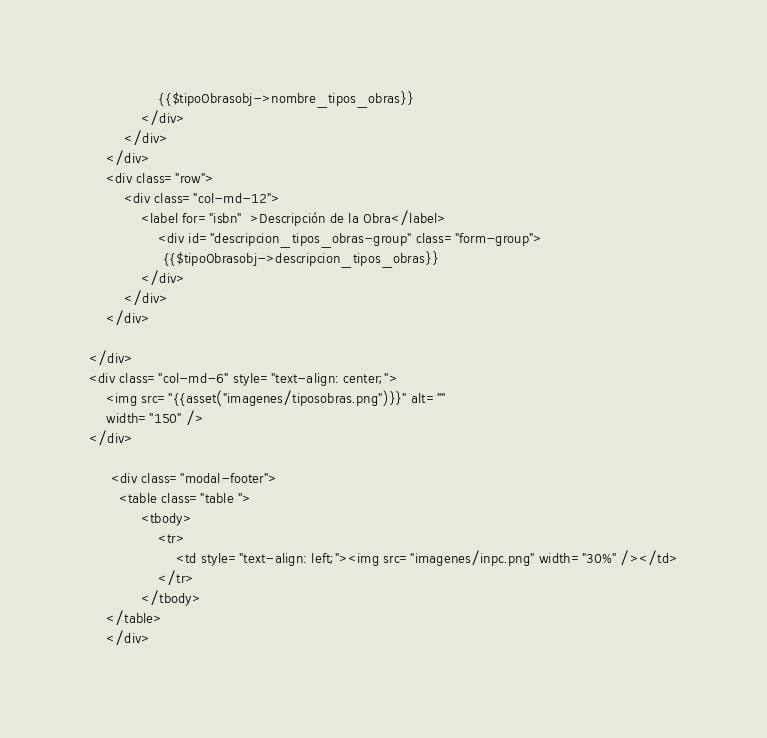<code> <loc_0><loc_0><loc_500><loc_500><_PHP_>                {{$tipoObrasobj->nombre_tipos_obras}}
            </div>
		</div>
	</div>
	<div class="row">
	    <div class="col-md-12">
	    	<label for="isbn"  >Descripción de la Obra</label>    
                <div id="descripcion_tipos_obras-group" class="form-group">
                 {{$tipoObrasobj->descripcion_tipos_obras}}
            </div>
	    </div>
	</div>
	
</div>
<div class="col-md-6" style="text-align: center;">
	<img src="{{asset("imagenes/tiposobras.png")}}" alt=""
	width="150" />
</div>

     <div class="modal-footer">
       <table class="table ">    
            <tbody>
                <tr>
                    <td style="text-align: left;"><img src="imagenes/inpc.png" width="30%" /></td>
                </tr>
            </tbody>
    </table>
    </div>  
</code> 